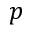Convert formula to latex. <formula><loc_0><loc_0><loc_500><loc_500>p</formula> 